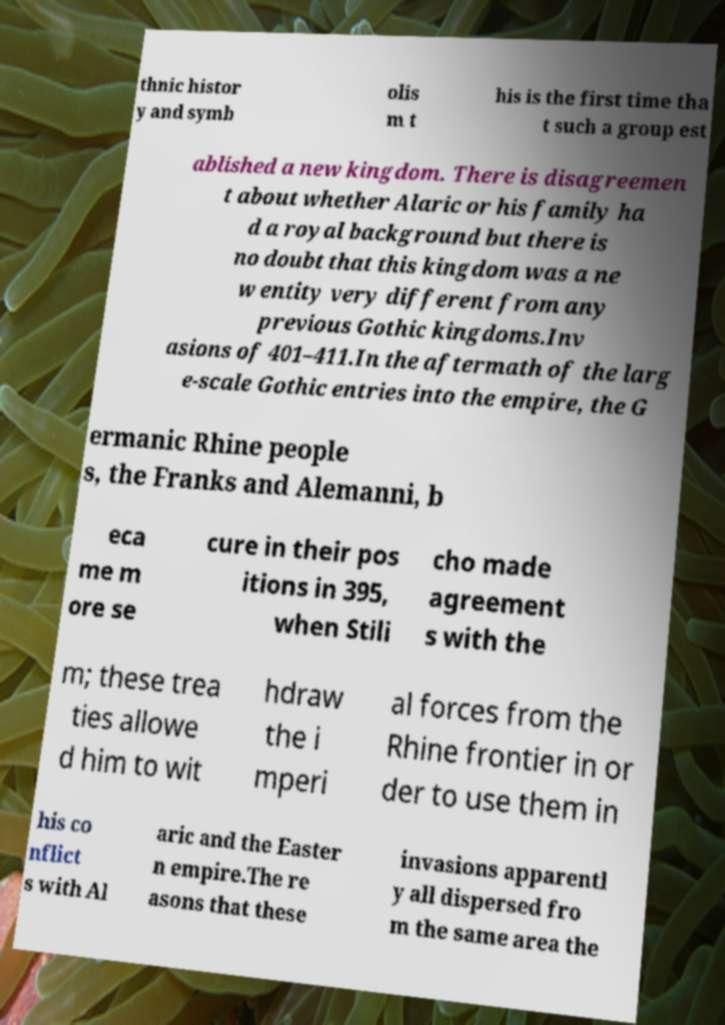There's text embedded in this image that I need extracted. Can you transcribe it verbatim? thnic histor y and symb olis m t his is the first time tha t such a group est ablished a new kingdom. There is disagreemen t about whether Alaric or his family ha d a royal background but there is no doubt that this kingdom was a ne w entity very different from any previous Gothic kingdoms.Inv asions of 401–411.In the aftermath of the larg e-scale Gothic entries into the empire, the G ermanic Rhine people s, the Franks and Alemanni, b eca me m ore se cure in their pos itions in 395, when Stili cho made agreement s with the m; these trea ties allowe d him to wit hdraw the i mperi al forces from the Rhine frontier in or der to use them in his co nflict s with Al aric and the Easter n empire.The re asons that these invasions apparentl y all dispersed fro m the same area the 